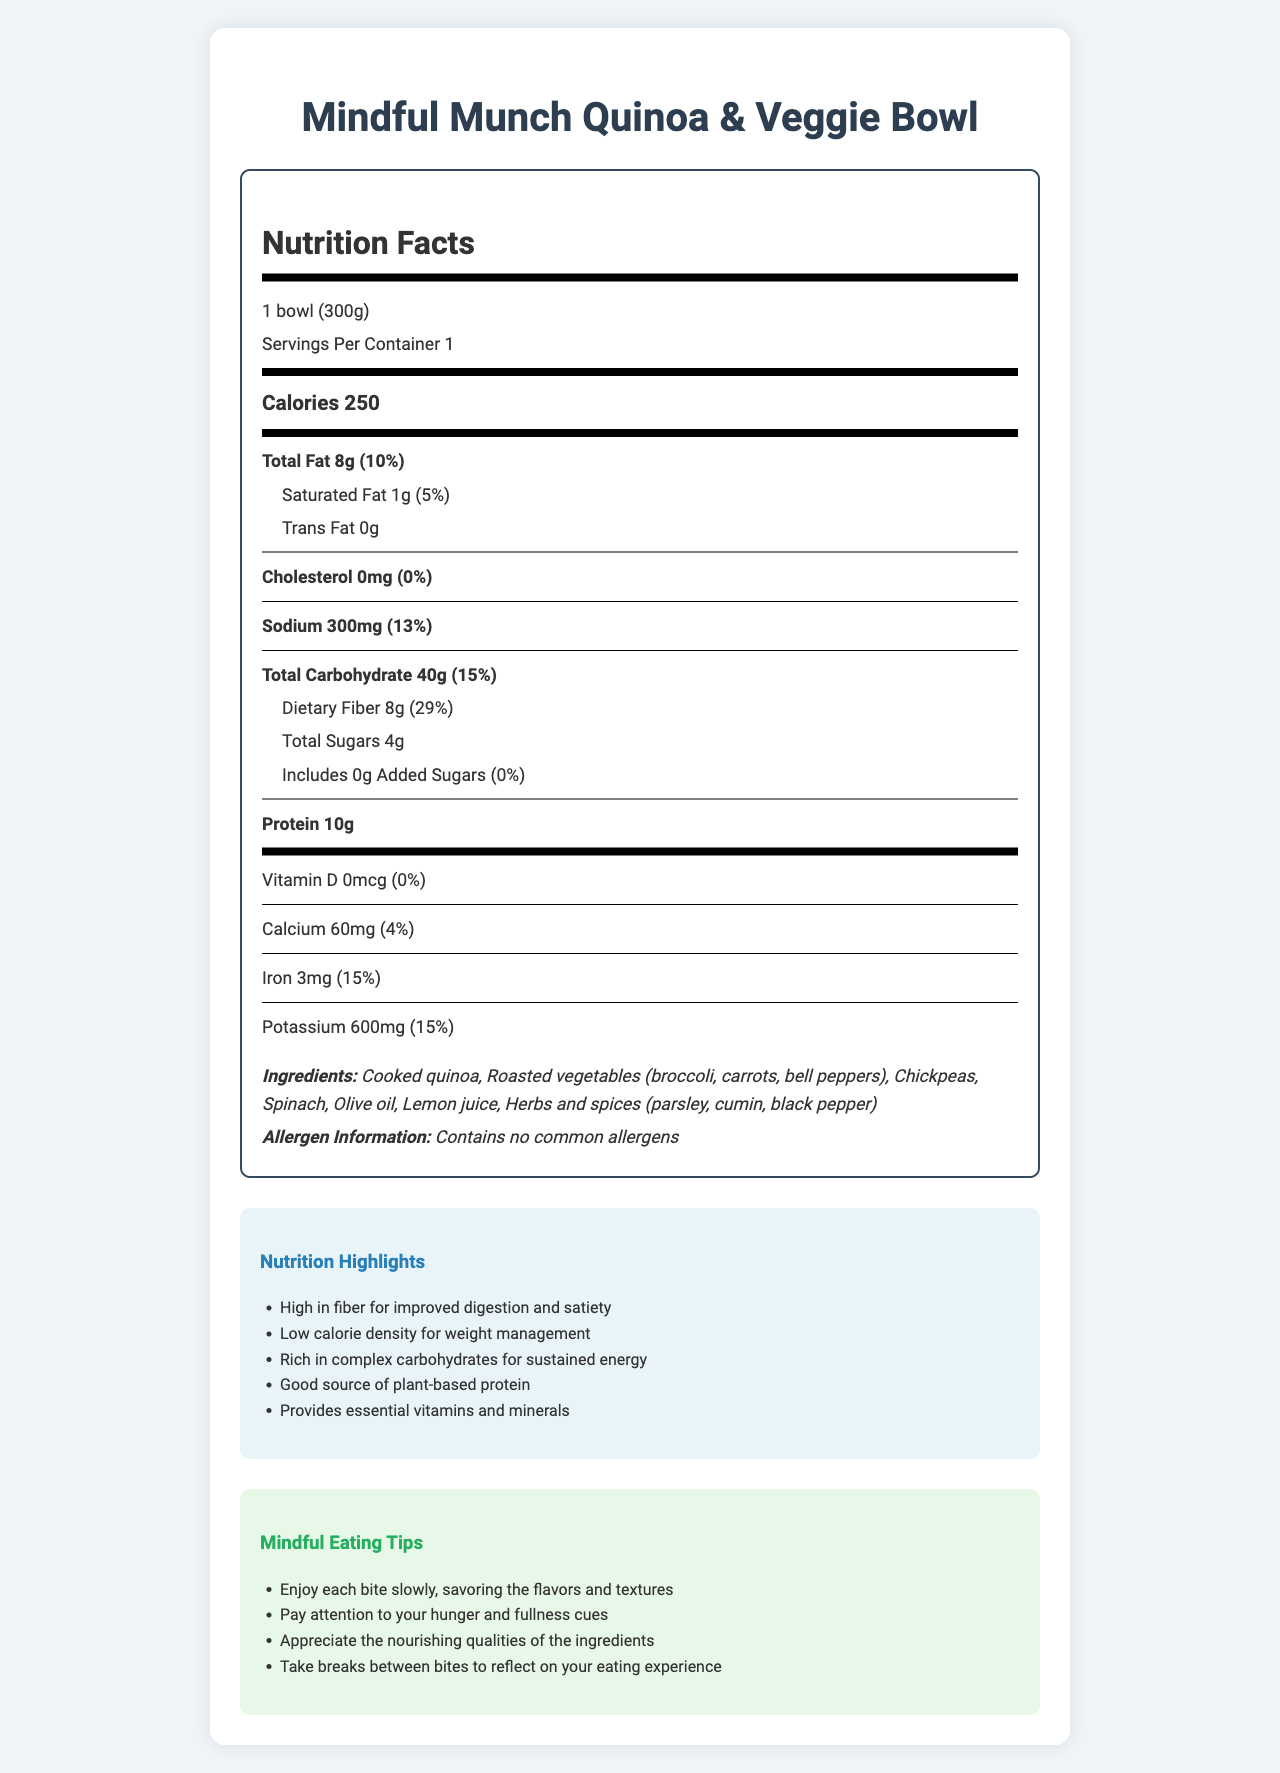what is the serving size of the Mindful Munch Quinoa & Veggie Bowl? The serving size is listed as "1 bowl (300g)" in the document.
Answer: 1 bowl (300g) how many calories are there per serving? The document specifies that there are 250 calories per serving.
Answer: 250 what percentage of the daily value does the total fat content represent? The total fat content is 8g, which is 10% of the daily value.
Answer: 10% what is the amount of dietary fiber in one serving? The document states there are 8g of dietary fiber per serving.
Answer: 8g how much sodium does one serving contain? The sodium content per serving is listed as 300mg.
Answer: 300mg what is the main ingredient in the Mindful Munch Quinoa & Veggie Bowl? The first ingredient listed is "Cooked quinoa," indicating it is the main ingredient.
Answer: Cooked quinoa What are the sources of calories in this food item? A. Fat and Protein B. Carbohydrates and Fiber C. Fat, Carbohydrates, and Protein The calorie breakdown shows that calories come from fat (72), carbohydrates (140), and protein (38).
Answer: C What is the daily iron value provided by this food item? A. 4% B. 15% C. 10% D. 20% The document states the iron content is 3mg, which provides 15% of the daily value.
Answer: B is this product high in fiber? The document lists 8g of dietary fiber, which is 29% of the daily value, indicating it is high in fiber.
Answer: Yes describe the main highlights of the nutrition details for this food item. The document highlights various nutritional benefits: high fiber content for improved digestion and satiety, low calorie density for weight management, richness in complex carbohydrates for sustained energy, provision of plant-based protein, and essential vitamins and minerals.
Answer: High in fiber, low calorie density, rich in complex carbohydrates, good source of plant-based protein, provides essential vitamins and minerals how does the mindful eating section suggest you enjoy each bite? The mindful eating tips recommend enjoying each bite slowly, savoring the flavors and textures.
Answer: Enjoy each bite slowly, savoring the flavors and textures how many calories are from protein in this food item? The calorie breakdown shows there are 38 calories from protein.
Answer: 38 calories how much calcium is in one serving? The document specifies there are 60mg of calcium per serving.
Answer: 60mg what is the percentage of daily value for potassium in one serving of this food item? The potassium content in one serving is 600mg, which is 15% of the daily value.
Answer: 15% how many total sugars are there in one serving? The document states there are 4g of total sugars per serving.
Answer: 4g is it possible to determine how much vitamin C is in this food item? The document does not provide information on the vitamin C content of the food item.
Answer: Not enough information 